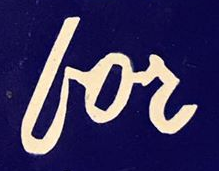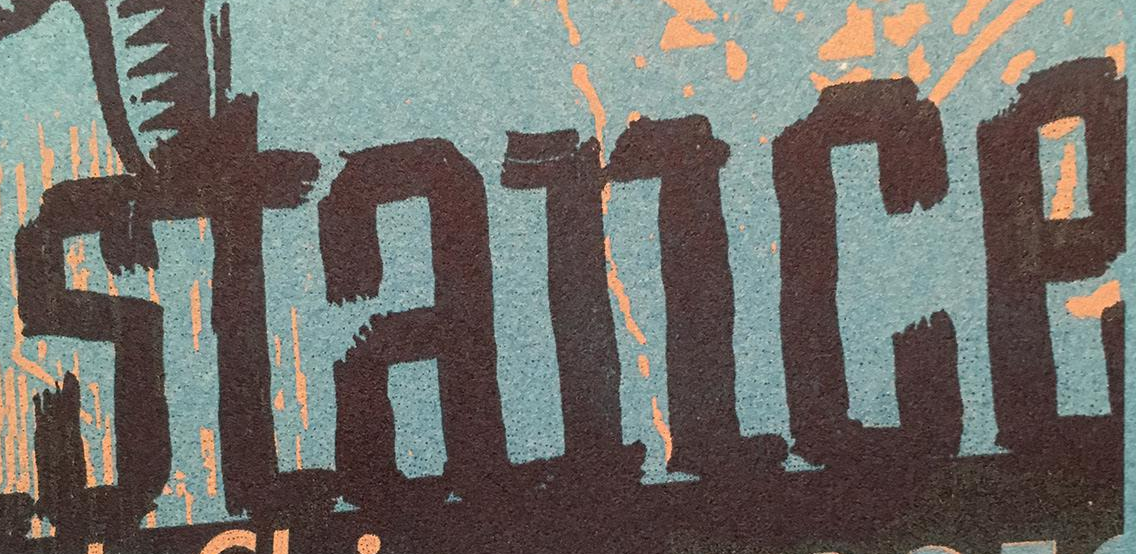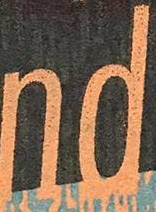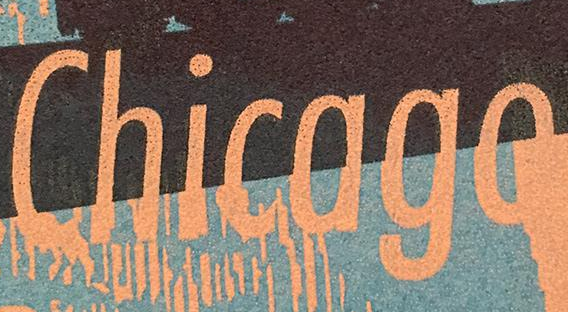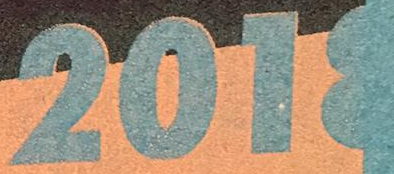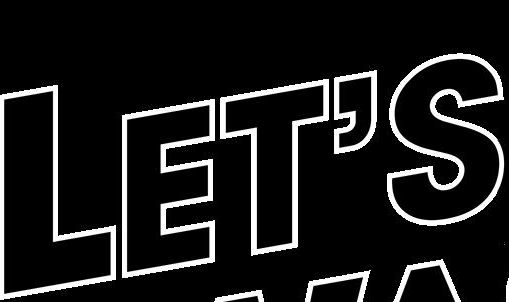What words are shown in these images in order, separated by a semicolon? for; stance; nd; Chicago; 2018; LET'S 